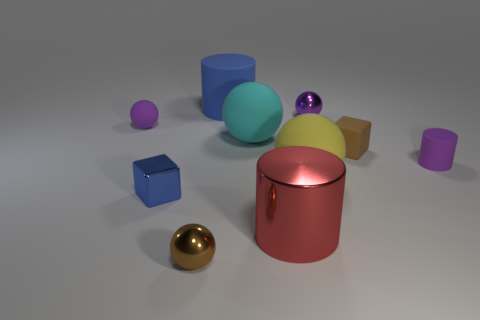Are there any reflective surfaces visible in the image? Yes, there are several objects with reflective surfaces in the image. The golden orb reflects its surroundings with a high level of clarity, as does the smaller purple sphere to its right. The crimson cylindrical object also has a reflective surface, as apparent by the lighter hue on its top and the visible reflections on its side. 